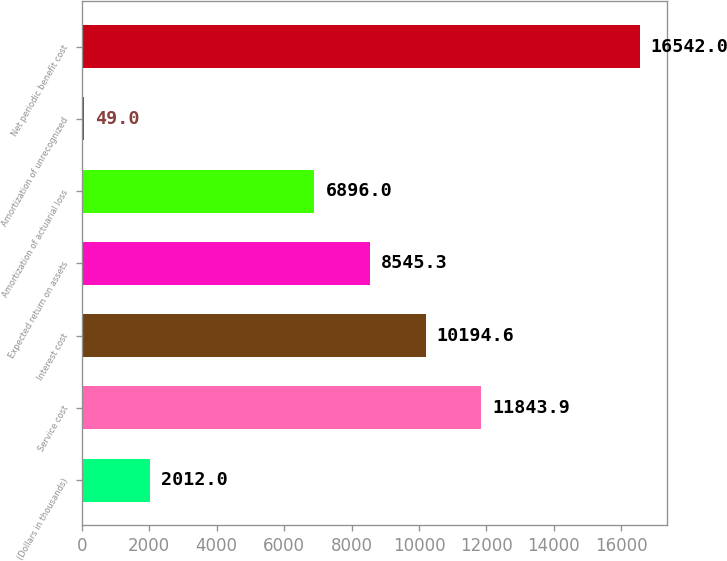Convert chart. <chart><loc_0><loc_0><loc_500><loc_500><bar_chart><fcel>(Dollars in thousands)<fcel>Service cost<fcel>Interest cost<fcel>Expected return on assets<fcel>Amortization of actuarial loss<fcel>Amortization of unrecognized<fcel>Net periodic benefit cost<nl><fcel>2012<fcel>11843.9<fcel>10194.6<fcel>8545.3<fcel>6896<fcel>49<fcel>16542<nl></chart> 